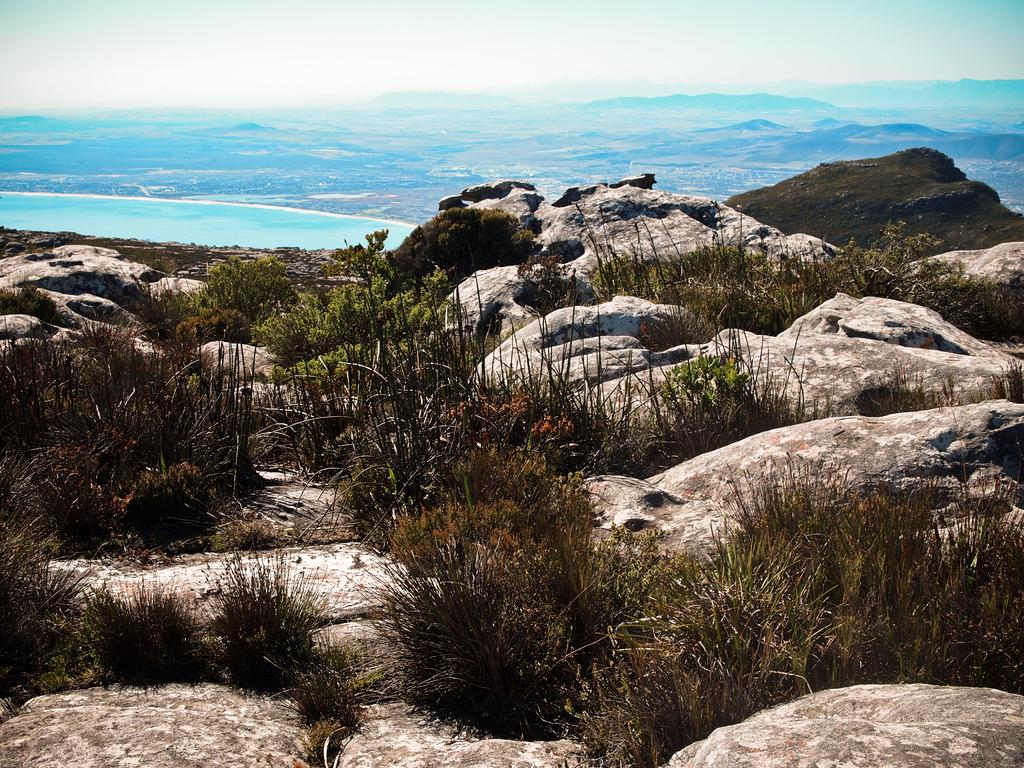What type of natural elements can be seen in the image? There are stones, plants, and grass in the image. Can you describe the vegetation in the image? The image contains plants and grass. What is visible in the background of the image? In the background of the image, there is a blue color thing. What type of insect can be seen crawling on the cherry in the image? There is no insect or cherry present in the image. 